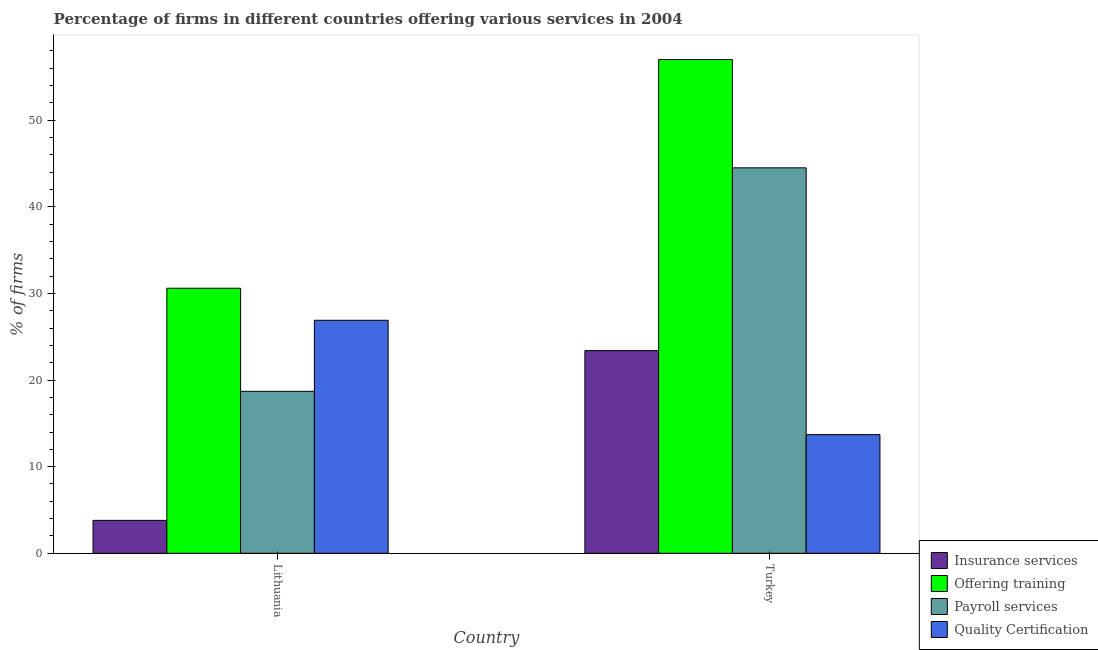How many different coloured bars are there?
Give a very brief answer. 4. Are the number of bars per tick equal to the number of legend labels?
Your response must be concise. Yes. Are the number of bars on each tick of the X-axis equal?
Keep it short and to the point. Yes. How many bars are there on the 2nd tick from the right?
Your response must be concise. 4. What is the label of the 2nd group of bars from the left?
Offer a very short reply. Turkey. What is the percentage of firms offering insurance services in Turkey?
Ensure brevity in your answer.  23.4. Across all countries, what is the maximum percentage of firms offering payroll services?
Ensure brevity in your answer.  44.5. In which country was the percentage of firms offering training minimum?
Your response must be concise. Lithuania. What is the total percentage of firms offering quality certification in the graph?
Make the answer very short. 40.6. What is the difference between the percentage of firms offering training in Lithuania and that in Turkey?
Make the answer very short. -26.4. What is the difference between the percentage of firms offering insurance services in Lithuania and the percentage of firms offering quality certification in Turkey?
Your answer should be compact. -9.9. What is the average percentage of firms offering quality certification per country?
Offer a very short reply. 20.3. What is the difference between the percentage of firms offering payroll services and percentage of firms offering training in Turkey?
Make the answer very short. -12.5. What is the ratio of the percentage of firms offering quality certification in Lithuania to that in Turkey?
Offer a terse response. 1.96. Is the percentage of firms offering payroll services in Lithuania less than that in Turkey?
Your answer should be very brief. Yes. In how many countries, is the percentage of firms offering insurance services greater than the average percentage of firms offering insurance services taken over all countries?
Provide a short and direct response. 1. What does the 2nd bar from the left in Lithuania represents?
Offer a terse response. Offering training. What does the 3rd bar from the right in Turkey represents?
Your response must be concise. Offering training. How many bars are there?
Provide a succinct answer. 8. Are all the bars in the graph horizontal?
Provide a short and direct response. No. How many countries are there in the graph?
Offer a terse response. 2. Are the values on the major ticks of Y-axis written in scientific E-notation?
Offer a terse response. No. Does the graph contain any zero values?
Make the answer very short. No. How are the legend labels stacked?
Your answer should be very brief. Vertical. What is the title of the graph?
Offer a very short reply. Percentage of firms in different countries offering various services in 2004. What is the label or title of the Y-axis?
Make the answer very short. % of firms. What is the % of firms of Insurance services in Lithuania?
Your answer should be very brief. 3.8. What is the % of firms in Offering training in Lithuania?
Make the answer very short. 30.6. What is the % of firms of Payroll services in Lithuania?
Your answer should be compact. 18.7. What is the % of firms of Quality Certification in Lithuania?
Keep it short and to the point. 26.9. What is the % of firms of Insurance services in Turkey?
Offer a very short reply. 23.4. What is the % of firms of Payroll services in Turkey?
Your answer should be very brief. 44.5. Across all countries, what is the maximum % of firms of Insurance services?
Provide a succinct answer. 23.4. Across all countries, what is the maximum % of firms in Offering training?
Provide a short and direct response. 57. Across all countries, what is the maximum % of firms of Payroll services?
Make the answer very short. 44.5. Across all countries, what is the maximum % of firms of Quality Certification?
Your response must be concise. 26.9. Across all countries, what is the minimum % of firms in Offering training?
Your response must be concise. 30.6. Across all countries, what is the minimum % of firms in Payroll services?
Make the answer very short. 18.7. Across all countries, what is the minimum % of firms in Quality Certification?
Keep it short and to the point. 13.7. What is the total % of firms of Insurance services in the graph?
Keep it short and to the point. 27.2. What is the total % of firms of Offering training in the graph?
Provide a short and direct response. 87.6. What is the total % of firms in Payroll services in the graph?
Provide a short and direct response. 63.2. What is the total % of firms in Quality Certification in the graph?
Provide a succinct answer. 40.6. What is the difference between the % of firms of Insurance services in Lithuania and that in Turkey?
Offer a terse response. -19.6. What is the difference between the % of firms of Offering training in Lithuania and that in Turkey?
Offer a very short reply. -26.4. What is the difference between the % of firms in Payroll services in Lithuania and that in Turkey?
Ensure brevity in your answer.  -25.8. What is the difference between the % of firms of Insurance services in Lithuania and the % of firms of Offering training in Turkey?
Your answer should be very brief. -53.2. What is the difference between the % of firms in Insurance services in Lithuania and the % of firms in Payroll services in Turkey?
Make the answer very short. -40.7. What is the average % of firms in Offering training per country?
Ensure brevity in your answer.  43.8. What is the average % of firms of Payroll services per country?
Provide a short and direct response. 31.6. What is the average % of firms in Quality Certification per country?
Your response must be concise. 20.3. What is the difference between the % of firms of Insurance services and % of firms of Offering training in Lithuania?
Provide a succinct answer. -26.8. What is the difference between the % of firms of Insurance services and % of firms of Payroll services in Lithuania?
Offer a terse response. -14.9. What is the difference between the % of firms of Insurance services and % of firms of Quality Certification in Lithuania?
Ensure brevity in your answer.  -23.1. What is the difference between the % of firms in Offering training and % of firms in Quality Certification in Lithuania?
Make the answer very short. 3.7. What is the difference between the % of firms of Payroll services and % of firms of Quality Certification in Lithuania?
Ensure brevity in your answer.  -8.2. What is the difference between the % of firms of Insurance services and % of firms of Offering training in Turkey?
Offer a terse response. -33.6. What is the difference between the % of firms of Insurance services and % of firms of Payroll services in Turkey?
Provide a short and direct response. -21.1. What is the difference between the % of firms in Insurance services and % of firms in Quality Certification in Turkey?
Make the answer very short. 9.7. What is the difference between the % of firms in Offering training and % of firms in Payroll services in Turkey?
Make the answer very short. 12.5. What is the difference between the % of firms of Offering training and % of firms of Quality Certification in Turkey?
Ensure brevity in your answer.  43.3. What is the difference between the % of firms in Payroll services and % of firms in Quality Certification in Turkey?
Ensure brevity in your answer.  30.8. What is the ratio of the % of firms in Insurance services in Lithuania to that in Turkey?
Your answer should be very brief. 0.16. What is the ratio of the % of firms of Offering training in Lithuania to that in Turkey?
Ensure brevity in your answer.  0.54. What is the ratio of the % of firms of Payroll services in Lithuania to that in Turkey?
Ensure brevity in your answer.  0.42. What is the ratio of the % of firms of Quality Certification in Lithuania to that in Turkey?
Ensure brevity in your answer.  1.96. What is the difference between the highest and the second highest % of firms in Insurance services?
Your answer should be compact. 19.6. What is the difference between the highest and the second highest % of firms of Offering training?
Make the answer very short. 26.4. What is the difference between the highest and the second highest % of firms of Payroll services?
Keep it short and to the point. 25.8. What is the difference between the highest and the lowest % of firms in Insurance services?
Ensure brevity in your answer.  19.6. What is the difference between the highest and the lowest % of firms in Offering training?
Keep it short and to the point. 26.4. What is the difference between the highest and the lowest % of firms of Payroll services?
Your response must be concise. 25.8. What is the difference between the highest and the lowest % of firms of Quality Certification?
Offer a terse response. 13.2. 